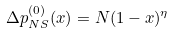Convert formula to latex. <formula><loc_0><loc_0><loc_500><loc_500>\Delta p _ { N S } ^ { ( 0 ) } ( x ) = N ( 1 - x ) ^ { \eta }</formula> 